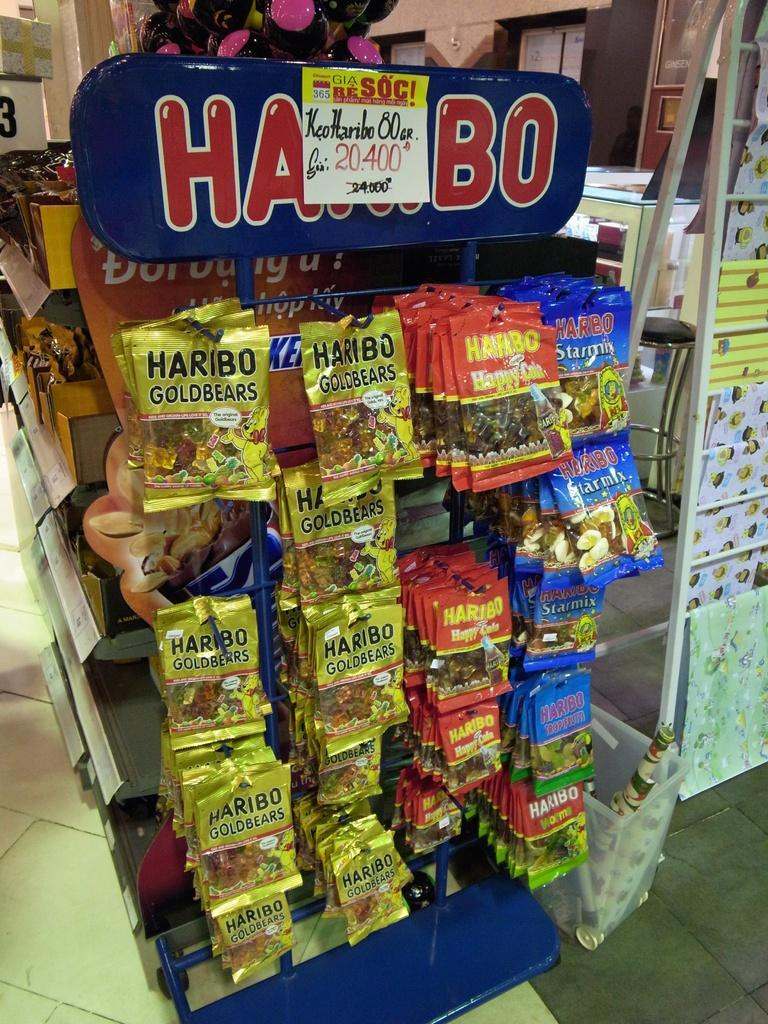<image>
Summarize the visual content of the image. Retail display of Haribo Gold Bears, Haribo Happy Cola and Haribo Starmix for sale. 